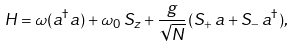<formula> <loc_0><loc_0><loc_500><loc_500>H = \omega ( a ^ { \dag } a ) + \omega _ { 0 } \, S _ { z } + \frac { g } { \sqrt { N } } \, ( S _ { + } \, a + S _ { - } \, a ^ { \dag } ) ,</formula> 